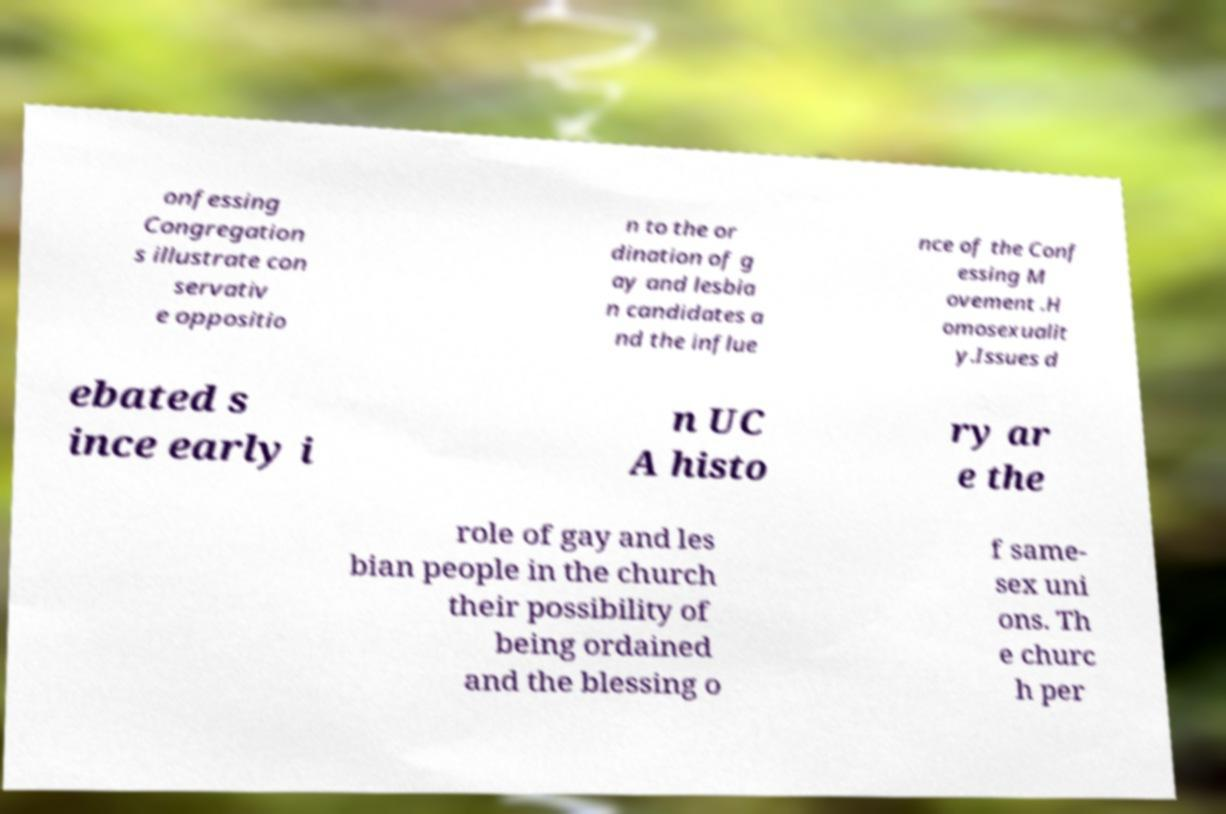Please read and relay the text visible in this image. What does it say? onfessing Congregation s illustrate con servativ e oppositio n to the or dination of g ay and lesbia n candidates a nd the influe nce of the Conf essing M ovement .H omosexualit y.Issues d ebated s ince early i n UC A histo ry ar e the role of gay and les bian people in the church their possibility of being ordained and the blessing o f same- sex uni ons. Th e churc h per 